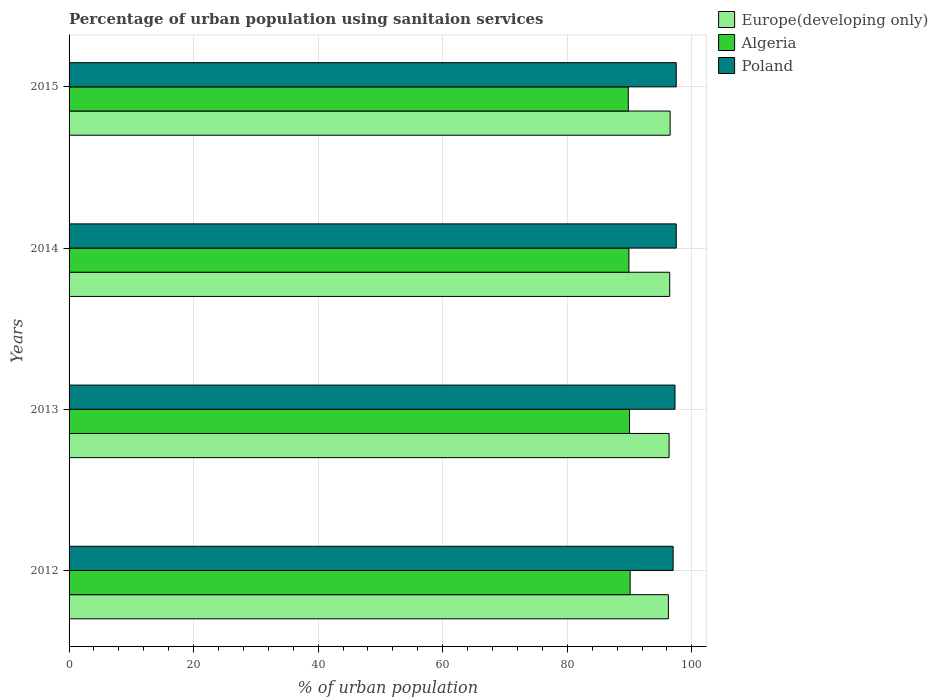How many different coloured bars are there?
Your response must be concise. 3. How many groups of bars are there?
Offer a terse response. 4. Are the number of bars per tick equal to the number of legend labels?
Provide a succinct answer. Yes. Are the number of bars on each tick of the Y-axis equal?
Offer a terse response. Yes. How many bars are there on the 3rd tick from the bottom?
Provide a short and direct response. 3. What is the label of the 2nd group of bars from the top?
Provide a succinct answer. 2014. In how many cases, is the number of bars for a given year not equal to the number of legend labels?
Provide a succinct answer. 0. What is the percentage of urban population using sanitaion services in Algeria in 2013?
Ensure brevity in your answer.  90. Across all years, what is the maximum percentage of urban population using sanitaion services in Algeria?
Keep it short and to the point. 90.1. Across all years, what is the minimum percentage of urban population using sanitaion services in Europe(developing only)?
Provide a succinct answer. 96.24. In which year was the percentage of urban population using sanitaion services in Algeria minimum?
Make the answer very short. 2015. What is the total percentage of urban population using sanitaion services in Poland in the graph?
Offer a terse response. 389.3. What is the difference between the percentage of urban population using sanitaion services in Europe(developing only) in 2012 and that in 2015?
Your answer should be compact. -0.28. What is the difference between the percentage of urban population using sanitaion services in Europe(developing only) in 2015 and the percentage of urban population using sanitaion services in Algeria in 2012?
Provide a succinct answer. 6.42. What is the average percentage of urban population using sanitaion services in Poland per year?
Keep it short and to the point. 97.33. In the year 2012, what is the difference between the percentage of urban population using sanitaion services in Poland and percentage of urban population using sanitaion services in Algeria?
Your answer should be very brief. 6.9. In how many years, is the percentage of urban population using sanitaion services in Algeria greater than 88 %?
Make the answer very short. 4. What is the ratio of the percentage of urban population using sanitaion services in Algeria in 2014 to that in 2015?
Offer a terse response. 1. Is the difference between the percentage of urban population using sanitaion services in Poland in 2012 and 2013 greater than the difference between the percentage of urban population using sanitaion services in Algeria in 2012 and 2013?
Your answer should be compact. No. What is the difference between the highest and the second highest percentage of urban population using sanitaion services in Europe(developing only)?
Keep it short and to the point. 0.07. In how many years, is the percentage of urban population using sanitaion services in Poland greater than the average percentage of urban population using sanitaion services in Poland taken over all years?
Your answer should be compact. 2. Is the sum of the percentage of urban population using sanitaion services in Poland in 2012 and 2014 greater than the maximum percentage of urban population using sanitaion services in Algeria across all years?
Your response must be concise. Yes. What does the 3rd bar from the top in 2013 represents?
Offer a terse response. Europe(developing only). What does the 1st bar from the bottom in 2015 represents?
Give a very brief answer. Europe(developing only). Are all the bars in the graph horizontal?
Provide a short and direct response. Yes. Are the values on the major ticks of X-axis written in scientific E-notation?
Offer a terse response. No. Does the graph contain grids?
Offer a terse response. Yes. What is the title of the graph?
Make the answer very short. Percentage of urban population using sanitaion services. Does "Spain" appear as one of the legend labels in the graph?
Keep it short and to the point. No. What is the label or title of the X-axis?
Provide a succinct answer. % of urban population. What is the label or title of the Y-axis?
Offer a terse response. Years. What is the % of urban population of Europe(developing only) in 2012?
Provide a short and direct response. 96.24. What is the % of urban population of Algeria in 2012?
Offer a very short reply. 90.1. What is the % of urban population in Poland in 2012?
Give a very brief answer. 97. What is the % of urban population in Europe(developing only) in 2013?
Your answer should be compact. 96.35. What is the % of urban population of Poland in 2013?
Provide a short and direct response. 97.3. What is the % of urban population in Europe(developing only) in 2014?
Give a very brief answer. 96.45. What is the % of urban population of Algeria in 2014?
Your response must be concise. 89.9. What is the % of urban population of Poland in 2014?
Provide a short and direct response. 97.5. What is the % of urban population of Europe(developing only) in 2015?
Your answer should be very brief. 96.52. What is the % of urban population of Algeria in 2015?
Provide a succinct answer. 89.8. What is the % of urban population in Poland in 2015?
Give a very brief answer. 97.5. Across all years, what is the maximum % of urban population of Europe(developing only)?
Provide a succinct answer. 96.52. Across all years, what is the maximum % of urban population in Algeria?
Make the answer very short. 90.1. Across all years, what is the maximum % of urban population in Poland?
Give a very brief answer. 97.5. Across all years, what is the minimum % of urban population in Europe(developing only)?
Provide a succinct answer. 96.24. Across all years, what is the minimum % of urban population of Algeria?
Make the answer very short. 89.8. Across all years, what is the minimum % of urban population of Poland?
Your response must be concise. 97. What is the total % of urban population of Europe(developing only) in the graph?
Your response must be concise. 385.56. What is the total % of urban population of Algeria in the graph?
Your answer should be compact. 359.8. What is the total % of urban population in Poland in the graph?
Your response must be concise. 389.3. What is the difference between the % of urban population of Europe(developing only) in 2012 and that in 2013?
Give a very brief answer. -0.11. What is the difference between the % of urban population of Algeria in 2012 and that in 2013?
Provide a succinct answer. 0.1. What is the difference between the % of urban population in Poland in 2012 and that in 2013?
Your response must be concise. -0.3. What is the difference between the % of urban population in Europe(developing only) in 2012 and that in 2014?
Offer a terse response. -0.21. What is the difference between the % of urban population in Poland in 2012 and that in 2014?
Your response must be concise. -0.5. What is the difference between the % of urban population of Europe(developing only) in 2012 and that in 2015?
Your answer should be compact. -0.28. What is the difference between the % of urban population in Europe(developing only) in 2013 and that in 2014?
Offer a terse response. -0.1. What is the difference between the % of urban population in Algeria in 2013 and that in 2014?
Ensure brevity in your answer.  0.1. What is the difference between the % of urban population of Poland in 2013 and that in 2014?
Provide a succinct answer. -0.2. What is the difference between the % of urban population of Europe(developing only) in 2013 and that in 2015?
Keep it short and to the point. -0.17. What is the difference between the % of urban population of Algeria in 2013 and that in 2015?
Keep it short and to the point. 0.2. What is the difference between the % of urban population in Europe(developing only) in 2014 and that in 2015?
Your answer should be compact. -0.07. What is the difference between the % of urban population of Algeria in 2014 and that in 2015?
Make the answer very short. 0.1. What is the difference between the % of urban population in Europe(developing only) in 2012 and the % of urban population in Algeria in 2013?
Ensure brevity in your answer.  6.24. What is the difference between the % of urban population in Europe(developing only) in 2012 and the % of urban population in Poland in 2013?
Your answer should be compact. -1.06. What is the difference between the % of urban population in Europe(developing only) in 2012 and the % of urban population in Algeria in 2014?
Offer a terse response. 6.34. What is the difference between the % of urban population of Europe(developing only) in 2012 and the % of urban population of Poland in 2014?
Provide a succinct answer. -1.26. What is the difference between the % of urban population of Europe(developing only) in 2012 and the % of urban population of Algeria in 2015?
Provide a succinct answer. 6.44. What is the difference between the % of urban population of Europe(developing only) in 2012 and the % of urban population of Poland in 2015?
Your answer should be compact. -1.26. What is the difference between the % of urban population of Europe(developing only) in 2013 and the % of urban population of Algeria in 2014?
Make the answer very short. 6.45. What is the difference between the % of urban population in Europe(developing only) in 2013 and the % of urban population in Poland in 2014?
Keep it short and to the point. -1.15. What is the difference between the % of urban population in Algeria in 2013 and the % of urban population in Poland in 2014?
Ensure brevity in your answer.  -7.5. What is the difference between the % of urban population in Europe(developing only) in 2013 and the % of urban population in Algeria in 2015?
Offer a very short reply. 6.55. What is the difference between the % of urban population in Europe(developing only) in 2013 and the % of urban population in Poland in 2015?
Your answer should be compact. -1.15. What is the difference between the % of urban population of Europe(developing only) in 2014 and the % of urban population of Algeria in 2015?
Your response must be concise. 6.65. What is the difference between the % of urban population in Europe(developing only) in 2014 and the % of urban population in Poland in 2015?
Make the answer very short. -1.05. What is the difference between the % of urban population in Algeria in 2014 and the % of urban population in Poland in 2015?
Your response must be concise. -7.6. What is the average % of urban population in Europe(developing only) per year?
Your response must be concise. 96.39. What is the average % of urban population of Algeria per year?
Offer a very short reply. 89.95. What is the average % of urban population in Poland per year?
Ensure brevity in your answer.  97.33. In the year 2012, what is the difference between the % of urban population in Europe(developing only) and % of urban population in Algeria?
Keep it short and to the point. 6.14. In the year 2012, what is the difference between the % of urban population of Europe(developing only) and % of urban population of Poland?
Provide a succinct answer. -0.76. In the year 2012, what is the difference between the % of urban population of Algeria and % of urban population of Poland?
Offer a very short reply. -6.9. In the year 2013, what is the difference between the % of urban population in Europe(developing only) and % of urban population in Algeria?
Ensure brevity in your answer.  6.35. In the year 2013, what is the difference between the % of urban population of Europe(developing only) and % of urban population of Poland?
Give a very brief answer. -0.95. In the year 2013, what is the difference between the % of urban population of Algeria and % of urban population of Poland?
Keep it short and to the point. -7.3. In the year 2014, what is the difference between the % of urban population in Europe(developing only) and % of urban population in Algeria?
Provide a short and direct response. 6.55. In the year 2014, what is the difference between the % of urban population of Europe(developing only) and % of urban population of Poland?
Provide a short and direct response. -1.05. In the year 2015, what is the difference between the % of urban population of Europe(developing only) and % of urban population of Algeria?
Give a very brief answer. 6.72. In the year 2015, what is the difference between the % of urban population of Europe(developing only) and % of urban population of Poland?
Your answer should be compact. -0.98. What is the ratio of the % of urban population of Europe(developing only) in 2012 to that in 2013?
Your answer should be compact. 1. What is the ratio of the % of urban population in Algeria in 2012 to that in 2013?
Keep it short and to the point. 1. What is the ratio of the % of urban population in Algeria in 2012 to that in 2015?
Offer a very short reply. 1. What is the ratio of the % of urban population of Algeria in 2013 to that in 2014?
Provide a short and direct response. 1. What is the ratio of the % of urban population of Poland in 2013 to that in 2014?
Make the answer very short. 1. What is the ratio of the % of urban population in Europe(developing only) in 2014 to that in 2015?
Keep it short and to the point. 1. What is the ratio of the % of urban population of Algeria in 2014 to that in 2015?
Your answer should be compact. 1. What is the ratio of the % of urban population in Poland in 2014 to that in 2015?
Offer a very short reply. 1. What is the difference between the highest and the second highest % of urban population in Europe(developing only)?
Offer a terse response. 0.07. What is the difference between the highest and the lowest % of urban population of Europe(developing only)?
Provide a short and direct response. 0.28. What is the difference between the highest and the lowest % of urban population of Algeria?
Make the answer very short. 0.3. What is the difference between the highest and the lowest % of urban population in Poland?
Give a very brief answer. 0.5. 